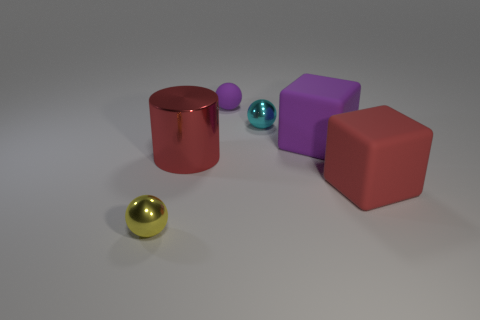What material is the tiny object to the left of the red thing behind the big red rubber block?
Make the answer very short. Metal. Is the number of small metal things behind the big purple matte block greater than the number of brown metallic cubes?
Ensure brevity in your answer.  Yes. Is there a gray shiny object?
Your answer should be compact. No. What is the color of the metal sphere on the left side of the tiny cyan metal sphere?
Offer a terse response. Yellow. There is a yellow sphere that is the same size as the cyan thing; what material is it?
Your answer should be very brief. Metal. How many other objects are there of the same material as the small yellow ball?
Provide a succinct answer. 2. What is the color of the thing that is both in front of the cylinder and to the right of the large red metallic thing?
Make the answer very short. Red. How many objects are purple matte objects right of the tiny purple matte sphere or small brown shiny cylinders?
Provide a short and direct response. 1. What number of other objects are the same color as the large shiny object?
Provide a short and direct response. 1. Is the number of small things on the right side of the yellow ball the same as the number of small metallic objects?
Your answer should be compact. Yes. 